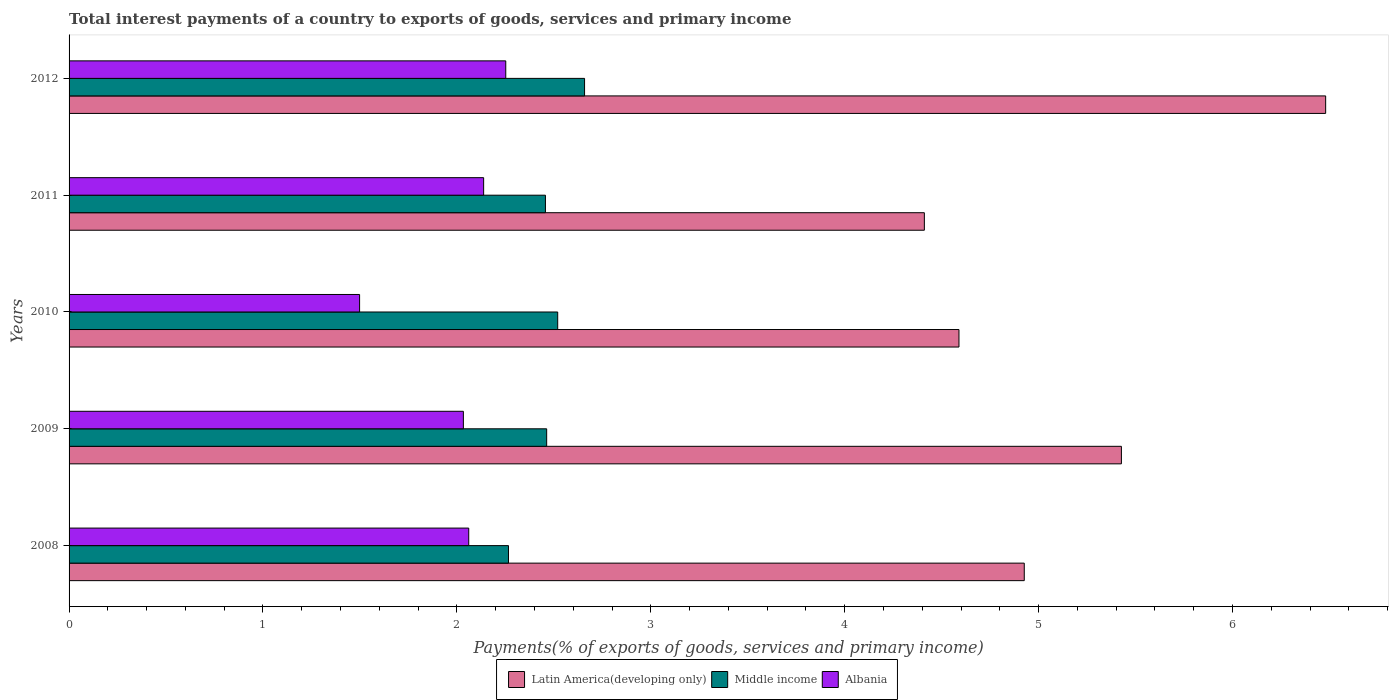How many different coloured bars are there?
Your answer should be compact. 3. How many groups of bars are there?
Your response must be concise. 5. How many bars are there on the 1st tick from the top?
Offer a terse response. 3. What is the label of the 4th group of bars from the top?
Provide a succinct answer. 2009. What is the total interest payments in Middle income in 2009?
Provide a short and direct response. 2.46. Across all years, what is the maximum total interest payments in Latin America(developing only)?
Offer a very short reply. 6.48. Across all years, what is the minimum total interest payments in Latin America(developing only)?
Keep it short and to the point. 4.41. In which year was the total interest payments in Middle income minimum?
Your answer should be very brief. 2008. What is the total total interest payments in Albania in the graph?
Ensure brevity in your answer.  9.98. What is the difference between the total interest payments in Latin America(developing only) in 2008 and that in 2011?
Your answer should be compact. 0.52. What is the difference between the total interest payments in Latin America(developing only) in 2009 and the total interest payments in Middle income in 2008?
Ensure brevity in your answer.  3.16. What is the average total interest payments in Latin America(developing only) per year?
Your answer should be very brief. 5.17. In the year 2009, what is the difference between the total interest payments in Albania and total interest payments in Middle income?
Make the answer very short. -0.43. What is the ratio of the total interest payments in Middle income in 2009 to that in 2010?
Your answer should be very brief. 0.98. Is the total interest payments in Albania in 2010 less than that in 2011?
Offer a terse response. Yes. What is the difference between the highest and the second highest total interest payments in Latin America(developing only)?
Make the answer very short. 1.05. What is the difference between the highest and the lowest total interest payments in Latin America(developing only)?
Give a very brief answer. 2.07. In how many years, is the total interest payments in Albania greater than the average total interest payments in Albania taken over all years?
Provide a succinct answer. 4. What does the 2nd bar from the top in 2009 represents?
Your answer should be very brief. Middle income. What does the 3rd bar from the bottom in 2008 represents?
Provide a short and direct response. Albania. Is it the case that in every year, the sum of the total interest payments in Albania and total interest payments in Latin America(developing only) is greater than the total interest payments in Middle income?
Provide a succinct answer. Yes. How many years are there in the graph?
Your answer should be compact. 5. What is the difference between two consecutive major ticks on the X-axis?
Provide a short and direct response. 1. Does the graph contain any zero values?
Make the answer very short. No. Does the graph contain grids?
Offer a very short reply. No. Where does the legend appear in the graph?
Offer a terse response. Bottom center. How are the legend labels stacked?
Offer a terse response. Horizontal. What is the title of the graph?
Make the answer very short. Total interest payments of a country to exports of goods, services and primary income. Does "St. Lucia" appear as one of the legend labels in the graph?
Make the answer very short. No. What is the label or title of the X-axis?
Make the answer very short. Payments(% of exports of goods, services and primary income). What is the Payments(% of exports of goods, services and primary income) of Latin America(developing only) in 2008?
Offer a very short reply. 4.93. What is the Payments(% of exports of goods, services and primary income) of Middle income in 2008?
Give a very brief answer. 2.27. What is the Payments(% of exports of goods, services and primary income) of Albania in 2008?
Your answer should be very brief. 2.06. What is the Payments(% of exports of goods, services and primary income) in Latin America(developing only) in 2009?
Your response must be concise. 5.43. What is the Payments(% of exports of goods, services and primary income) of Middle income in 2009?
Offer a terse response. 2.46. What is the Payments(% of exports of goods, services and primary income) of Albania in 2009?
Offer a terse response. 2.03. What is the Payments(% of exports of goods, services and primary income) in Latin America(developing only) in 2010?
Offer a very short reply. 4.59. What is the Payments(% of exports of goods, services and primary income) in Middle income in 2010?
Your answer should be very brief. 2.52. What is the Payments(% of exports of goods, services and primary income) of Albania in 2010?
Offer a very short reply. 1.5. What is the Payments(% of exports of goods, services and primary income) in Latin America(developing only) in 2011?
Offer a very short reply. 4.41. What is the Payments(% of exports of goods, services and primary income) in Middle income in 2011?
Offer a very short reply. 2.46. What is the Payments(% of exports of goods, services and primary income) in Albania in 2011?
Provide a short and direct response. 2.14. What is the Payments(% of exports of goods, services and primary income) of Latin America(developing only) in 2012?
Your answer should be very brief. 6.48. What is the Payments(% of exports of goods, services and primary income) of Middle income in 2012?
Give a very brief answer. 2.66. What is the Payments(% of exports of goods, services and primary income) of Albania in 2012?
Your response must be concise. 2.25. Across all years, what is the maximum Payments(% of exports of goods, services and primary income) in Latin America(developing only)?
Ensure brevity in your answer.  6.48. Across all years, what is the maximum Payments(% of exports of goods, services and primary income) in Middle income?
Ensure brevity in your answer.  2.66. Across all years, what is the maximum Payments(% of exports of goods, services and primary income) in Albania?
Offer a terse response. 2.25. Across all years, what is the minimum Payments(% of exports of goods, services and primary income) of Latin America(developing only)?
Give a very brief answer. 4.41. Across all years, what is the minimum Payments(% of exports of goods, services and primary income) of Middle income?
Offer a very short reply. 2.27. Across all years, what is the minimum Payments(% of exports of goods, services and primary income) of Albania?
Provide a succinct answer. 1.5. What is the total Payments(% of exports of goods, services and primary income) of Latin America(developing only) in the graph?
Make the answer very short. 25.83. What is the total Payments(% of exports of goods, services and primary income) of Middle income in the graph?
Offer a very short reply. 12.36. What is the total Payments(% of exports of goods, services and primary income) of Albania in the graph?
Your answer should be compact. 9.98. What is the difference between the Payments(% of exports of goods, services and primary income) of Latin America(developing only) in 2008 and that in 2009?
Your answer should be compact. -0.5. What is the difference between the Payments(% of exports of goods, services and primary income) in Middle income in 2008 and that in 2009?
Keep it short and to the point. -0.2. What is the difference between the Payments(% of exports of goods, services and primary income) in Albania in 2008 and that in 2009?
Make the answer very short. 0.03. What is the difference between the Payments(% of exports of goods, services and primary income) of Latin America(developing only) in 2008 and that in 2010?
Provide a succinct answer. 0.34. What is the difference between the Payments(% of exports of goods, services and primary income) in Middle income in 2008 and that in 2010?
Make the answer very short. -0.25. What is the difference between the Payments(% of exports of goods, services and primary income) in Albania in 2008 and that in 2010?
Your response must be concise. 0.56. What is the difference between the Payments(% of exports of goods, services and primary income) of Latin America(developing only) in 2008 and that in 2011?
Ensure brevity in your answer.  0.52. What is the difference between the Payments(% of exports of goods, services and primary income) of Middle income in 2008 and that in 2011?
Offer a very short reply. -0.19. What is the difference between the Payments(% of exports of goods, services and primary income) in Albania in 2008 and that in 2011?
Provide a short and direct response. -0.08. What is the difference between the Payments(% of exports of goods, services and primary income) of Latin America(developing only) in 2008 and that in 2012?
Make the answer very short. -1.55. What is the difference between the Payments(% of exports of goods, services and primary income) in Middle income in 2008 and that in 2012?
Give a very brief answer. -0.39. What is the difference between the Payments(% of exports of goods, services and primary income) in Albania in 2008 and that in 2012?
Your answer should be very brief. -0.19. What is the difference between the Payments(% of exports of goods, services and primary income) in Latin America(developing only) in 2009 and that in 2010?
Give a very brief answer. 0.84. What is the difference between the Payments(% of exports of goods, services and primary income) in Middle income in 2009 and that in 2010?
Provide a short and direct response. -0.06. What is the difference between the Payments(% of exports of goods, services and primary income) of Albania in 2009 and that in 2010?
Offer a very short reply. 0.54. What is the difference between the Payments(% of exports of goods, services and primary income) in Latin America(developing only) in 2009 and that in 2011?
Give a very brief answer. 1.02. What is the difference between the Payments(% of exports of goods, services and primary income) of Middle income in 2009 and that in 2011?
Provide a succinct answer. 0.01. What is the difference between the Payments(% of exports of goods, services and primary income) of Albania in 2009 and that in 2011?
Provide a succinct answer. -0.1. What is the difference between the Payments(% of exports of goods, services and primary income) of Latin America(developing only) in 2009 and that in 2012?
Make the answer very short. -1.05. What is the difference between the Payments(% of exports of goods, services and primary income) in Middle income in 2009 and that in 2012?
Your answer should be very brief. -0.2. What is the difference between the Payments(% of exports of goods, services and primary income) of Albania in 2009 and that in 2012?
Make the answer very short. -0.22. What is the difference between the Payments(% of exports of goods, services and primary income) of Latin America(developing only) in 2010 and that in 2011?
Provide a short and direct response. 0.18. What is the difference between the Payments(% of exports of goods, services and primary income) of Middle income in 2010 and that in 2011?
Provide a succinct answer. 0.06. What is the difference between the Payments(% of exports of goods, services and primary income) in Albania in 2010 and that in 2011?
Your response must be concise. -0.64. What is the difference between the Payments(% of exports of goods, services and primary income) in Latin America(developing only) in 2010 and that in 2012?
Keep it short and to the point. -1.89. What is the difference between the Payments(% of exports of goods, services and primary income) of Middle income in 2010 and that in 2012?
Offer a terse response. -0.14. What is the difference between the Payments(% of exports of goods, services and primary income) of Albania in 2010 and that in 2012?
Give a very brief answer. -0.75. What is the difference between the Payments(% of exports of goods, services and primary income) of Latin America(developing only) in 2011 and that in 2012?
Make the answer very short. -2.07. What is the difference between the Payments(% of exports of goods, services and primary income) in Middle income in 2011 and that in 2012?
Ensure brevity in your answer.  -0.2. What is the difference between the Payments(% of exports of goods, services and primary income) in Albania in 2011 and that in 2012?
Your response must be concise. -0.11. What is the difference between the Payments(% of exports of goods, services and primary income) in Latin America(developing only) in 2008 and the Payments(% of exports of goods, services and primary income) in Middle income in 2009?
Make the answer very short. 2.46. What is the difference between the Payments(% of exports of goods, services and primary income) of Latin America(developing only) in 2008 and the Payments(% of exports of goods, services and primary income) of Albania in 2009?
Offer a very short reply. 2.89. What is the difference between the Payments(% of exports of goods, services and primary income) in Middle income in 2008 and the Payments(% of exports of goods, services and primary income) in Albania in 2009?
Keep it short and to the point. 0.23. What is the difference between the Payments(% of exports of goods, services and primary income) in Latin America(developing only) in 2008 and the Payments(% of exports of goods, services and primary income) in Middle income in 2010?
Keep it short and to the point. 2.41. What is the difference between the Payments(% of exports of goods, services and primary income) in Latin America(developing only) in 2008 and the Payments(% of exports of goods, services and primary income) in Albania in 2010?
Keep it short and to the point. 3.43. What is the difference between the Payments(% of exports of goods, services and primary income) of Middle income in 2008 and the Payments(% of exports of goods, services and primary income) of Albania in 2010?
Make the answer very short. 0.77. What is the difference between the Payments(% of exports of goods, services and primary income) of Latin America(developing only) in 2008 and the Payments(% of exports of goods, services and primary income) of Middle income in 2011?
Keep it short and to the point. 2.47. What is the difference between the Payments(% of exports of goods, services and primary income) in Latin America(developing only) in 2008 and the Payments(% of exports of goods, services and primary income) in Albania in 2011?
Ensure brevity in your answer.  2.79. What is the difference between the Payments(% of exports of goods, services and primary income) of Middle income in 2008 and the Payments(% of exports of goods, services and primary income) of Albania in 2011?
Your response must be concise. 0.13. What is the difference between the Payments(% of exports of goods, services and primary income) of Latin America(developing only) in 2008 and the Payments(% of exports of goods, services and primary income) of Middle income in 2012?
Your answer should be very brief. 2.27. What is the difference between the Payments(% of exports of goods, services and primary income) of Latin America(developing only) in 2008 and the Payments(% of exports of goods, services and primary income) of Albania in 2012?
Offer a very short reply. 2.67. What is the difference between the Payments(% of exports of goods, services and primary income) in Middle income in 2008 and the Payments(% of exports of goods, services and primary income) in Albania in 2012?
Your answer should be very brief. 0.01. What is the difference between the Payments(% of exports of goods, services and primary income) in Latin America(developing only) in 2009 and the Payments(% of exports of goods, services and primary income) in Middle income in 2010?
Your answer should be very brief. 2.91. What is the difference between the Payments(% of exports of goods, services and primary income) of Latin America(developing only) in 2009 and the Payments(% of exports of goods, services and primary income) of Albania in 2010?
Provide a short and direct response. 3.93. What is the difference between the Payments(% of exports of goods, services and primary income) in Middle income in 2009 and the Payments(% of exports of goods, services and primary income) in Albania in 2010?
Your answer should be very brief. 0.96. What is the difference between the Payments(% of exports of goods, services and primary income) in Latin America(developing only) in 2009 and the Payments(% of exports of goods, services and primary income) in Middle income in 2011?
Your answer should be very brief. 2.97. What is the difference between the Payments(% of exports of goods, services and primary income) of Latin America(developing only) in 2009 and the Payments(% of exports of goods, services and primary income) of Albania in 2011?
Your response must be concise. 3.29. What is the difference between the Payments(% of exports of goods, services and primary income) in Middle income in 2009 and the Payments(% of exports of goods, services and primary income) in Albania in 2011?
Your answer should be compact. 0.33. What is the difference between the Payments(% of exports of goods, services and primary income) in Latin America(developing only) in 2009 and the Payments(% of exports of goods, services and primary income) in Middle income in 2012?
Offer a terse response. 2.77. What is the difference between the Payments(% of exports of goods, services and primary income) of Latin America(developing only) in 2009 and the Payments(% of exports of goods, services and primary income) of Albania in 2012?
Provide a short and direct response. 3.18. What is the difference between the Payments(% of exports of goods, services and primary income) in Middle income in 2009 and the Payments(% of exports of goods, services and primary income) in Albania in 2012?
Provide a short and direct response. 0.21. What is the difference between the Payments(% of exports of goods, services and primary income) in Latin America(developing only) in 2010 and the Payments(% of exports of goods, services and primary income) in Middle income in 2011?
Offer a very short reply. 2.13. What is the difference between the Payments(% of exports of goods, services and primary income) in Latin America(developing only) in 2010 and the Payments(% of exports of goods, services and primary income) in Albania in 2011?
Offer a very short reply. 2.45. What is the difference between the Payments(% of exports of goods, services and primary income) of Middle income in 2010 and the Payments(% of exports of goods, services and primary income) of Albania in 2011?
Make the answer very short. 0.38. What is the difference between the Payments(% of exports of goods, services and primary income) in Latin America(developing only) in 2010 and the Payments(% of exports of goods, services and primary income) in Middle income in 2012?
Offer a very short reply. 1.93. What is the difference between the Payments(% of exports of goods, services and primary income) of Latin America(developing only) in 2010 and the Payments(% of exports of goods, services and primary income) of Albania in 2012?
Your response must be concise. 2.34. What is the difference between the Payments(% of exports of goods, services and primary income) in Middle income in 2010 and the Payments(% of exports of goods, services and primary income) in Albania in 2012?
Keep it short and to the point. 0.27. What is the difference between the Payments(% of exports of goods, services and primary income) of Latin America(developing only) in 2011 and the Payments(% of exports of goods, services and primary income) of Middle income in 2012?
Ensure brevity in your answer.  1.75. What is the difference between the Payments(% of exports of goods, services and primary income) in Latin America(developing only) in 2011 and the Payments(% of exports of goods, services and primary income) in Albania in 2012?
Offer a terse response. 2.16. What is the difference between the Payments(% of exports of goods, services and primary income) of Middle income in 2011 and the Payments(% of exports of goods, services and primary income) of Albania in 2012?
Offer a terse response. 0.2. What is the average Payments(% of exports of goods, services and primary income) in Latin America(developing only) per year?
Your answer should be very brief. 5.17. What is the average Payments(% of exports of goods, services and primary income) of Middle income per year?
Offer a very short reply. 2.47. What is the average Payments(% of exports of goods, services and primary income) in Albania per year?
Make the answer very short. 2. In the year 2008, what is the difference between the Payments(% of exports of goods, services and primary income) in Latin America(developing only) and Payments(% of exports of goods, services and primary income) in Middle income?
Ensure brevity in your answer.  2.66. In the year 2008, what is the difference between the Payments(% of exports of goods, services and primary income) in Latin America(developing only) and Payments(% of exports of goods, services and primary income) in Albania?
Offer a very short reply. 2.87. In the year 2008, what is the difference between the Payments(% of exports of goods, services and primary income) in Middle income and Payments(% of exports of goods, services and primary income) in Albania?
Your answer should be very brief. 0.21. In the year 2009, what is the difference between the Payments(% of exports of goods, services and primary income) of Latin America(developing only) and Payments(% of exports of goods, services and primary income) of Middle income?
Your answer should be compact. 2.96. In the year 2009, what is the difference between the Payments(% of exports of goods, services and primary income) of Latin America(developing only) and Payments(% of exports of goods, services and primary income) of Albania?
Keep it short and to the point. 3.39. In the year 2009, what is the difference between the Payments(% of exports of goods, services and primary income) of Middle income and Payments(% of exports of goods, services and primary income) of Albania?
Offer a very short reply. 0.43. In the year 2010, what is the difference between the Payments(% of exports of goods, services and primary income) in Latin America(developing only) and Payments(% of exports of goods, services and primary income) in Middle income?
Provide a short and direct response. 2.07. In the year 2010, what is the difference between the Payments(% of exports of goods, services and primary income) of Latin America(developing only) and Payments(% of exports of goods, services and primary income) of Albania?
Offer a very short reply. 3.09. In the year 2010, what is the difference between the Payments(% of exports of goods, services and primary income) of Middle income and Payments(% of exports of goods, services and primary income) of Albania?
Keep it short and to the point. 1.02. In the year 2011, what is the difference between the Payments(% of exports of goods, services and primary income) in Latin America(developing only) and Payments(% of exports of goods, services and primary income) in Middle income?
Your answer should be very brief. 1.95. In the year 2011, what is the difference between the Payments(% of exports of goods, services and primary income) in Latin America(developing only) and Payments(% of exports of goods, services and primary income) in Albania?
Offer a very short reply. 2.27. In the year 2011, what is the difference between the Payments(% of exports of goods, services and primary income) of Middle income and Payments(% of exports of goods, services and primary income) of Albania?
Your answer should be very brief. 0.32. In the year 2012, what is the difference between the Payments(% of exports of goods, services and primary income) in Latin America(developing only) and Payments(% of exports of goods, services and primary income) in Middle income?
Make the answer very short. 3.82. In the year 2012, what is the difference between the Payments(% of exports of goods, services and primary income) of Latin America(developing only) and Payments(% of exports of goods, services and primary income) of Albania?
Offer a very short reply. 4.23. In the year 2012, what is the difference between the Payments(% of exports of goods, services and primary income) of Middle income and Payments(% of exports of goods, services and primary income) of Albania?
Give a very brief answer. 0.41. What is the ratio of the Payments(% of exports of goods, services and primary income) in Latin America(developing only) in 2008 to that in 2009?
Provide a succinct answer. 0.91. What is the ratio of the Payments(% of exports of goods, services and primary income) in Albania in 2008 to that in 2009?
Your response must be concise. 1.01. What is the ratio of the Payments(% of exports of goods, services and primary income) of Latin America(developing only) in 2008 to that in 2010?
Offer a very short reply. 1.07. What is the ratio of the Payments(% of exports of goods, services and primary income) in Middle income in 2008 to that in 2010?
Provide a short and direct response. 0.9. What is the ratio of the Payments(% of exports of goods, services and primary income) of Albania in 2008 to that in 2010?
Provide a short and direct response. 1.38. What is the ratio of the Payments(% of exports of goods, services and primary income) in Latin America(developing only) in 2008 to that in 2011?
Offer a very short reply. 1.12. What is the ratio of the Payments(% of exports of goods, services and primary income) of Middle income in 2008 to that in 2011?
Your answer should be very brief. 0.92. What is the ratio of the Payments(% of exports of goods, services and primary income) of Latin America(developing only) in 2008 to that in 2012?
Your answer should be very brief. 0.76. What is the ratio of the Payments(% of exports of goods, services and primary income) of Middle income in 2008 to that in 2012?
Your answer should be very brief. 0.85. What is the ratio of the Payments(% of exports of goods, services and primary income) in Albania in 2008 to that in 2012?
Provide a short and direct response. 0.92. What is the ratio of the Payments(% of exports of goods, services and primary income) in Latin America(developing only) in 2009 to that in 2010?
Keep it short and to the point. 1.18. What is the ratio of the Payments(% of exports of goods, services and primary income) of Middle income in 2009 to that in 2010?
Provide a short and direct response. 0.98. What is the ratio of the Payments(% of exports of goods, services and primary income) of Albania in 2009 to that in 2010?
Provide a succinct answer. 1.36. What is the ratio of the Payments(% of exports of goods, services and primary income) of Latin America(developing only) in 2009 to that in 2011?
Your answer should be very brief. 1.23. What is the ratio of the Payments(% of exports of goods, services and primary income) in Middle income in 2009 to that in 2011?
Your response must be concise. 1. What is the ratio of the Payments(% of exports of goods, services and primary income) in Albania in 2009 to that in 2011?
Ensure brevity in your answer.  0.95. What is the ratio of the Payments(% of exports of goods, services and primary income) of Latin America(developing only) in 2009 to that in 2012?
Offer a very short reply. 0.84. What is the ratio of the Payments(% of exports of goods, services and primary income) of Middle income in 2009 to that in 2012?
Ensure brevity in your answer.  0.93. What is the ratio of the Payments(% of exports of goods, services and primary income) in Albania in 2009 to that in 2012?
Your response must be concise. 0.9. What is the ratio of the Payments(% of exports of goods, services and primary income) in Latin America(developing only) in 2010 to that in 2011?
Ensure brevity in your answer.  1.04. What is the ratio of the Payments(% of exports of goods, services and primary income) of Middle income in 2010 to that in 2011?
Your answer should be very brief. 1.03. What is the ratio of the Payments(% of exports of goods, services and primary income) of Albania in 2010 to that in 2011?
Provide a short and direct response. 0.7. What is the ratio of the Payments(% of exports of goods, services and primary income) in Latin America(developing only) in 2010 to that in 2012?
Your answer should be compact. 0.71. What is the ratio of the Payments(% of exports of goods, services and primary income) in Middle income in 2010 to that in 2012?
Give a very brief answer. 0.95. What is the ratio of the Payments(% of exports of goods, services and primary income) in Albania in 2010 to that in 2012?
Provide a succinct answer. 0.67. What is the ratio of the Payments(% of exports of goods, services and primary income) of Latin America(developing only) in 2011 to that in 2012?
Give a very brief answer. 0.68. What is the ratio of the Payments(% of exports of goods, services and primary income) of Middle income in 2011 to that in 2012?
Your answer should be very brief. 0.92. What is the ratio of the Payments(% of exports of goods, services and primary income) in Albania in 2011 to that in 2012?
Your answer should be very brief. 0.95. What is the difference between the highest and the second highest Payments(% of exports of goods, services and primary income) of Latin America(developing only)?
Provide a short and direct response. 1.05. What is the difference between the highest and the second highest Payments(% of exports of goods, services and primary income) in Middle income?
Offer a terse response. 0.14. What is the difference between the highest and the second highest Payments(% of exports of goods, services and primary income) of Albania?
Offer a terse response. 0.11. What is the difference between the highest and the lowest Payments(% of exports of goods, services and primary income) in Latin America(developing only)?
Give a very brief answer. 2.07. What is the difference between the highest and the lowest Payments(% of exports of goods, services and primary income) in Middle income?
Ensure brevity in your answer.  0.39. What is the difference between the highest and the lowest Payments(% of exports of goods, services and primary income) of Albania?
Ensure brevity in your answer.  0.75. 